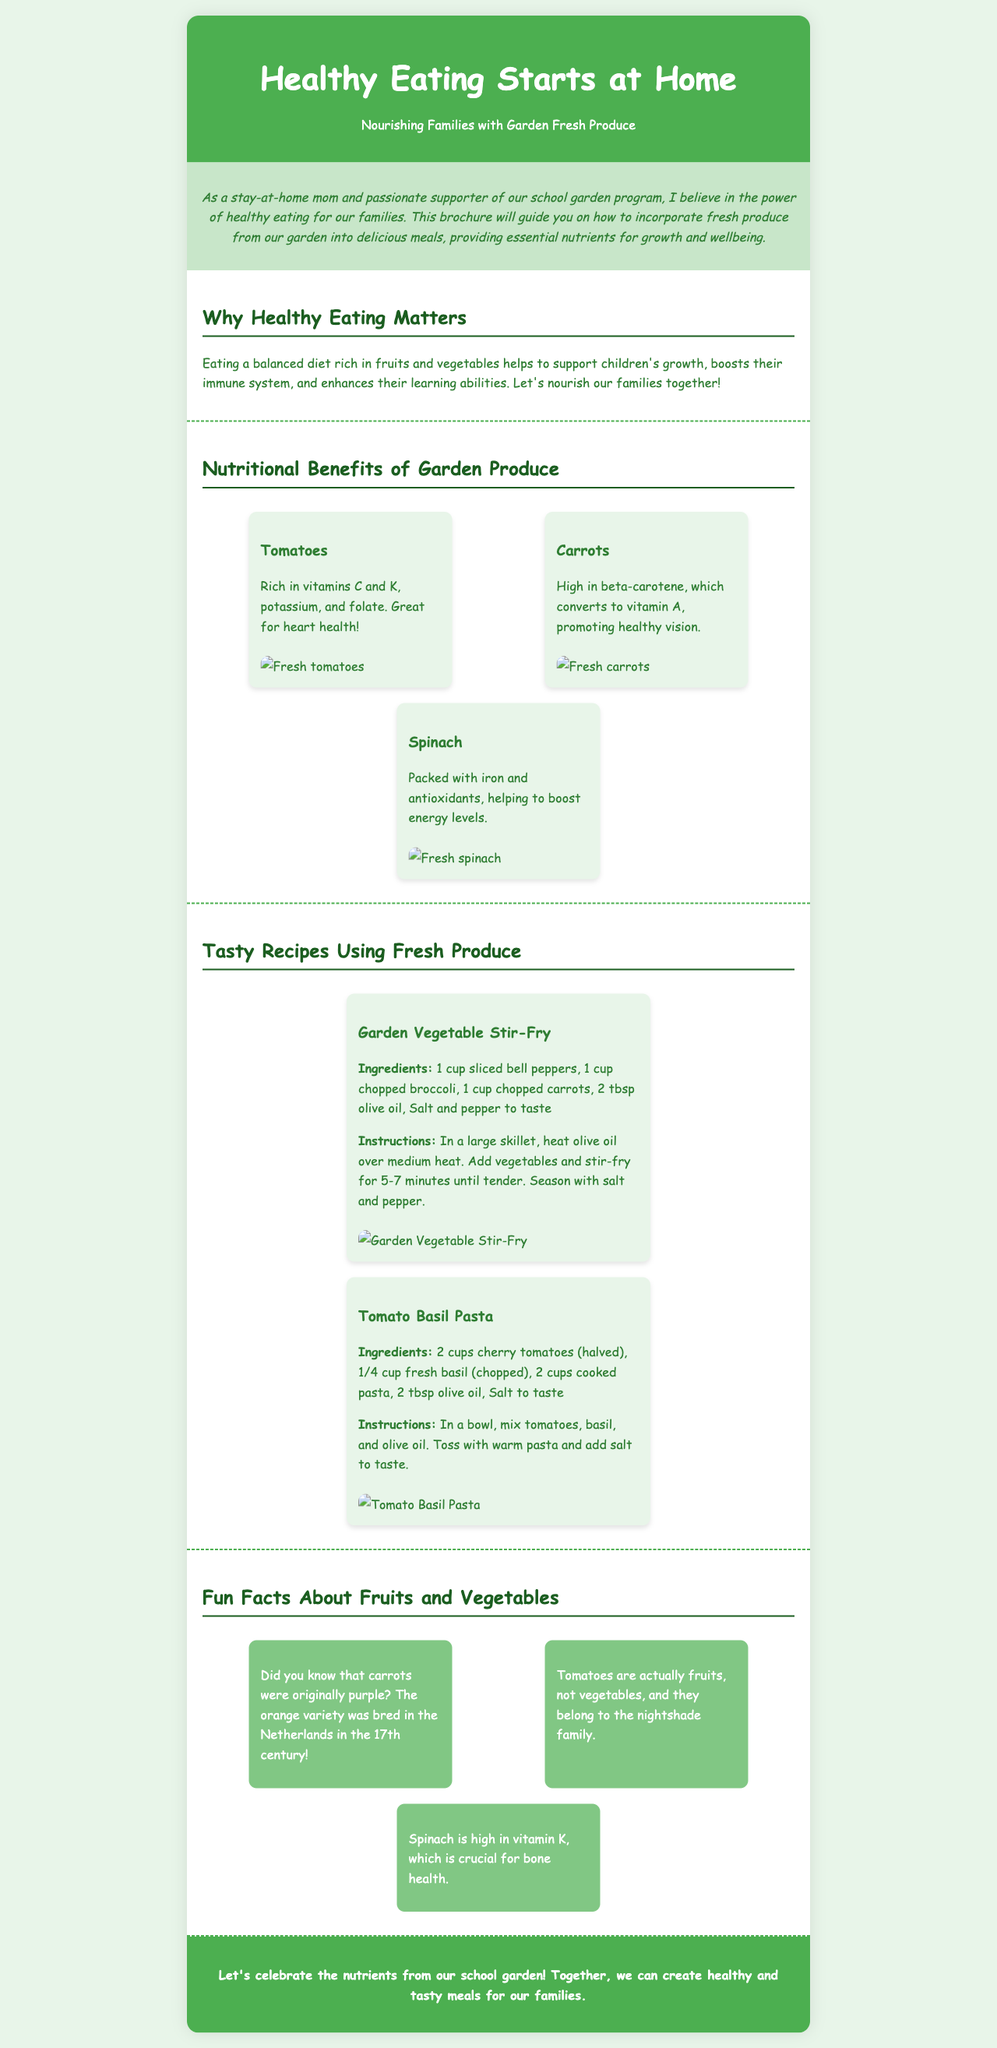What is the title of the brochure? The title is prominently displayed at the top of the document, indicating the main theme of the brochure.
Answer: Healthy Eating Starts at Home What is the main purpose of the brochure? The purpose is explained in the introductory section, highlighting the focus on healthy eating and its importance for families.
Answer: Promoting healthy eating for families Which vegetable is mentioned as being high in beta-carotene? This specific information is found within the nutritional benefits section that details various garden produce.
Answer: Carrots How many recipes are provided in the brochure? The recipe section lists the number of recipes that are included in the document.
Answer: 2 What nutrient is spinach particularly known for? This information is stated in the nutritional benefits section regarding spinach.
Answer: Iron What fun fact is stated about carrots? This fact is found in the fun facts section and provides historical context about the carrot's color.
Answer: Originally purple Who is the target audience of this brochure? The intended audience is suggested in the introductory paragraph which emphasizes families.
Answer: Families What type of document is this? The structure and content of the document indicate its purpose and layout.
Answer: Brochure What color scheme is predominantly used in the brochure? The overall color palette used in the document conveys its theme and visual appeal.
Answer: Green and white 